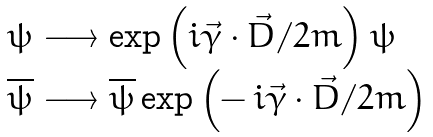Convert formula to latex. <formula><loc_0><loc_0><loc_500><loc_500>\begin{array} { l } \psi \longrightarrow \exp \left ( i \vec { \gamma } \cdot \vec { D } / 2 m \right ) \psi \\ \overline { \psi } \longrightarrow \overline { \psi } \exp \left ( - \, i \vec { \gamma } \cdot \vec { D } / 2 m \right ) \end{array}</formula> 